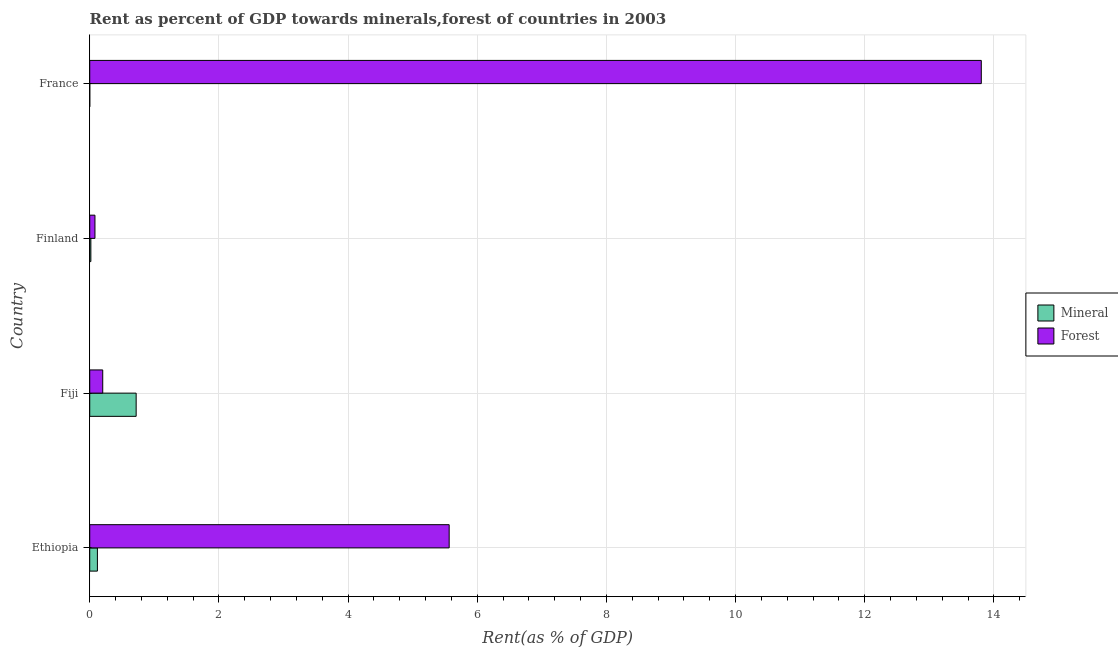Are the number of bars per tick equal to the number of legend labels?
Make the answer very short. Yes. How many bars are there on the 2nd tick from the top?
Offer a very short reply. 2. How many bars are there on the 4th tick from the bottom?
Give a very brief answer. 2. In how many cases, is the number of bars for a given country not equal to the number of legend labels?
Keep it short and to the point. 0. What is the forest rent in Finland?
Give a very brief answer. 0.08. Across all countries, what is the maximum forest rent?
Offer a terse response. 13.81. Across all countries, what is the minimum mineral rent?
Keep it short and to the point. 0. In which country was the forest rent maximum?
Your response must be concise. France. In which country was the mineral rent minimum?
Ensure brevity in your answer.  France. What is the total forest rent in the graph?
Your response must be concise. 19.65. What is the difference between the mineral rent in Ethiopia and that in Finland?
Your answer should be compact. 0.1. What is the difference between the mineral rent in Fiji and the forest rent in France?
Keep it short and to the point. -13.09. What is the average forest rent per country?
Keep it short and to the point. 4.91. What is the difference between the mineral rent and forest rent in Fiji?
Keep it short and to the point. 0.52. What is the ratio of the mineral rent in Ethiopia to that in France?
Your answer should be compact. 405.65. Is the mineral rent in Ethiopia less than that in Fiji?
Make the answer very short. Yes. Is the difference between the mineral rent in Finland and France greater than the difference between the forest rent in Finland and France?
Your answer should be very brief. Yes. What is the difference between the highest and the second highest forest rent?
Offer a terse response. 8.24. What is the difference between the highest and the lowest forest rent?
Your answer should be compact. 13.72. What does the 1st bar from the top in Fiji represents?
Provide a short and direct response. Forest. What does the 1st bar from the bottom in Fiji represents?
Offer a very short reply. Mineral. Are all the bars in the graph horizontal?
Ensure brevity in your answer.  Yes. How many countries are there in the graph?
Your response must be concise. 4. Are the values on the major ticks of X-axis written in scientific E-notation?
Provide a succinct answer. No. Does the graph contain any zero values?
Your response must be concise. No. Does the graph contain grids?
Your response must be concise. Yes. Where does the legend appear in the graph?
Offer a terse response. Center right. What is the title of the graph?
Give a very brief answer. Rent as percent of GDP towards minerals,forest of countries in 2003. Does "Food" appear as one of the legend labels in the graph?
Your answer should be very brief. No. What is the label or title of the X-axis?
Give a very brief answer. Rent(as % of GDP). What is the label or title of the Y-axis?
Your answer should be compact. Country. What is the Rent(as % of GDP) of Mineral in Ethiopia?
Your answer should be compact. 0.12. What is the Rent(as % of GDP) of Forest in Ethiopia?
Provide a succinct answer. 5.57. What is the Rent(as % of GDP) of Mineral in Fiji?
Ensure brevity in your answer.  0.72. What is the Rent(as % of GDP) of Forest in Fiji?
Your response must be concise. 0.2. What is the Rent(as % of GDP) in Mineral in Finland?
Your answer should be compact. 0.02. What is the Rent(as % of GDP) in Forest in Finland?
Offer a very short reply. 0.08. What is the Rent(as % of GDP) of Mineral in France?
Your answer should be compact. 0. What is the Rent(as % of GDP) of Forest in France?
Ensure brevity in your answer.  13.81. Across all countries, what is the maximum Rent(as % of GDP) in Mineral?
Your answer should be compact. 0.72. Across all countries, what is the maximum Rent(as % of GDP) in Forest?
Make the answer very short. 13.81. Across all countries, what is the minimum Rent(as % of GDP) in Mineral?
Ensure brevity in your answer.  0. Across all countries, what is the minimum Rent(as % of GDP) in Forest?
Offer a very short reply. 0.08. What is the total Rent(as % of GDP) in Mineral in the graph?
Your response must be concise. 0.86. What is the total Rent(as % of GDP) in Forest in the graph?
Offer a very short reply. 19.65. What is the difference between the Rent(as % of GDP) of Mineral in Ethiopia and that in Fiji?
Keep it short and to the point. -0.6. What is the difference between the Rent(as % of GDP) in Forest in Ethiopia and that in Fiji?
Ensure brevity in your answer.  5.36. What is the difference between the Rent(as % of GDP) of Mineral in Ethiopia and that in Finland?
Your answer should be very brief. 0.1. What is the difference between the Rent(as % of GDP) of Forest in Ethiopia and that in Finland?
Provide a succinct answer. 5.49. What is the difference between the Rent(as % of GDP) of Mineral in Ethiopia and that in France?
Provide a succinct answer. 0.12. What is the difference between the Rent(as % of GDP) of Forest in Ethiopia and that in France?
Your answer should be very brief. -8.24. What is the difference between the Rent(as % of GDP) of Mineral in Fiji and that in Finland?
Provide a short and direct response. 0.7. What is the difference between the Rent(as % of GDP) in Forest in Fiji and that in Finland?
Ensure brevity in your answer.  0.12. What is the difference between the Rent(as % of GDP) of Mineral in Fiji and that in France?
Your answer should be compact. 0.72. What is the difference between the Rent(as % of GDP) in Forest in Fiji and that in France?
Provide a short and direct response. -13.6. What is the difference between the Rent(as % of GDP) of Mineral in Finland and that in France?
Keep it short and to the point. 0.02. What is the difference between the Rent(as % of GDP) of Forest in Finland and that in France?
Offer a terse response. -13.72. What is the difference between the Rent(as % of GDP) in Mineral in Ethiopia and the Rent(as % of GDP) in Forest in Fiji?
Your answer should be compact. -0.08. What is the difference between the Rent(as % of GDP) of Mineral in Ethiopia and the Rent(as % of GDP) of Forest in Finland?
Ensure brevity in your answer.  0.04. What is the difference between the Rent(as % of GDP) in Mineral in Ethiopia and the Rent(as % of GDP) in Forest in France?
Provide a short and direct response. -13.69. What is the difference between the Rent(as % of GDP) of Mineral in Fiji and the Rent(as % of GDP) of Forest in Finland?
Ensure brevity in your answer.  0.64. What is the difference between the Rent(as % of GDP) of Mineral in Fiji and the Rent(as % of GDP) of Forest in France?
Keep it short and to the point. -13.09. What is the difference between the Rent(as % of GDP) in Mineral in Finland and the Rent(as % of GDP) in Forest in France?
Your response must be concise. -13.79. What is the average Rent(as % of GDP) in Mineral per country?
Your response must be concise. 0.21. What is the average Rent(as % of GDP) in Forest per country?
Provide a succinct answer. 4.91. What is the difference between the Rent(as % of GDP) of Mineral and Rent(as % of GDP) of Forest in Ethiopia?
Keep it short and to the point. -5.45. What is the difference between the Rent(as % of GDP) in Mineral and Rent(as % of GDP) in Forest in Fiji?
Keep it short and to the point. 0.52. What is the difference between the Rent(as % of GDP) in Mineral and Rent(as % of GDP) in Forest in Finland?
Offer a terse response. -0.06. What is the difference between the Rent(as % of GDP) in Mineral and Rent(as % of GDP) in Forest in France?
Your answer should be very brief. -13.81. What is the ratio of the Rent(as % of GDP) of Mineral in Ethiopia to that in Fiji?
Your response must be concise. 0.17. What is the ratio of the Rent(as % of GDP) of Forest in Ethiopia to that in Fiji?
Your response must be concise. 27.65. What is the ratio of the Rent(as % of GDP) in Mineral in Ethiopia to that in Finland?
Provide a short and direct response. 6.8. What is the ratio of the Rent(as % of GDP) in Forest in Ethiopia to that in Finland?
Give a very brief answer. 68.82. What is the ratio of the Rent(as % of GDP) of Mineral in Ethiopia to that in France?
Your response must be concise. 405.65. What is the ratio of the Rent(as % of GDP) of Forest in Ethiopia to that in France?
Your answer should be compact. 0.4. What is the ratio of the Rent(as % of GDP) in Mineral in Fiji to that in Finland?
Give a very brief answer. 41.06. What is the ratio of the Rent(as % of GDP) of Forest in Fiji to that in Finland?
Keep it short and to the point. 2.49. What is the ratio of the Rent(as % of GDP) of Mineral in Fiji to that in France?
Give a very brief answer. 2451.11. What is the ratio of the Rent(as % of GDP) in Forest in Fiji to that in France?
Make the answer very short. 0.01. What is the ratio of the Rent(as % of GDP) in Mineral in Finland to that in France?
Offer a very short reply. 59.7. What is the ratio of the Rent(as % of GDP) in Forest in Finland to that in France?
Ensure brevity in your answer.  0.01. What is the difference between the highest and the second highest Rent(as % of GDP) of Mineral?
Your answer should be compact. 0.6. What is the difference between the highest and the second highest Rent(as % of GDP) of Forest?
Offer a very short reply. 8.24. What is the difference between the highest and the lowest Rent(as % of GDP) in Mineral?
Your answer should be very brief. 0.72. What is the difference between the highest and the lowest Rent(as % of GDP) of Forest?
Provide a succinct answer. 13.72. 